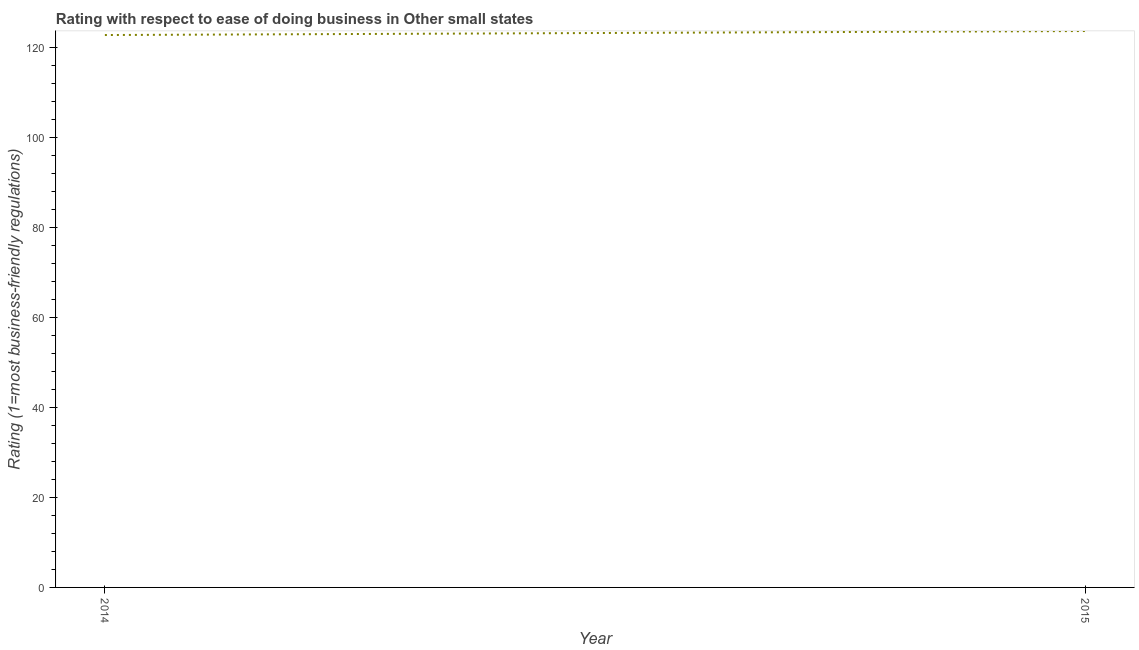What is the ease of doing business index in 2014?
Give a very brief answer. 122.72. Across all years, what is the maximum ease of doing business index?
Ensure brevity in your answer.  123.61. Across all years, what is the minimum ease of doing business index?
Ensure brevity in your answer.  122.72. In which year was the ease of doing business index maximum?
Ensure brevity in your answer.  2015. What is the sum of the ease of doing business index?
Offer a very short reply. 246.33. What is the difference between the ease of doing business index in 2014 and 2015?
Keep it short and to the point. -0.89. What is the average ease of doing business index per year?
Give a very brief answer. 123.17. What is the median ease of doing business index?
Keep it short and to the point. 123.17. Do a majority of the years between 2015 and 2014 (inclusive) have ease of doing business index greater than 80 ?
Your response must be concise. No. What is the ratio of the ease of doing business index in 2014 to that in 2015?
Your answer should be very brief. 0.99. Does the ease of doing business index monotonically increase over the years?
Your answer should be very brief. Yes. How many years are there in the graph?
Your response must be concise. 2. Does the graph contain any zero values?
Give a very brief answer. No. What is the title of the graph?
Provide a succinct answer. Rating with respect to ease of doing business in Other small states. What is the label or title of the Y-axis?
Your answer should be very brief. Rating (1=most business-friendly regulations). What is the Rating (1=most business-friendly regulations) in 2014?
Offer a terse response. 122.72. What is the Rating (1=most business-friendly regulations) of 2015?
Ensure brevity in your answer.  123.61. What is the difference between the Rating (1=most business-friendly regulations) in 2014 and 2015?
Make the answer very short. -0.89. What is the ratio of the Rating (1=most business-friendly regulations) in 2014 to that in 2015?
Make the answer very short. 0.99. 